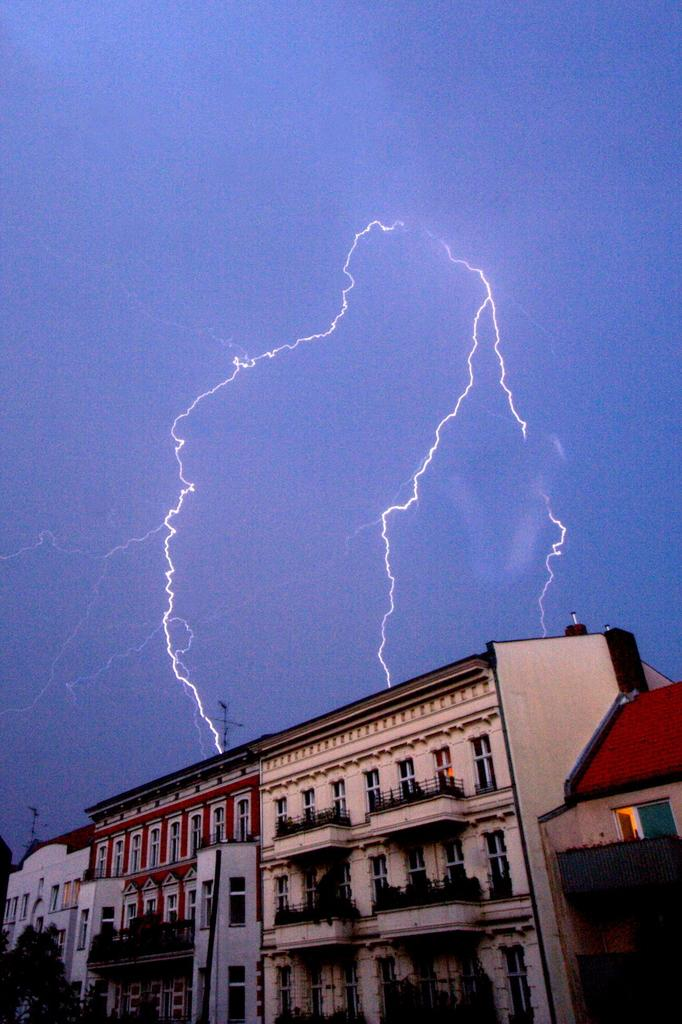What type of structure is located at the bottom of the image? There is a building at the bottom of the image. What are the vertical supports in the image? There are poles in the image. What are the barriers made of in the image? There are fences in the image. What type of vegetation can be seen in the image? There are trees and plants in the image. What can be used for entering or exiting the building in the image? There are doors in the image. What is visible in the sky in the background of the image? There is thunder visible in the sky in the background of the image. How many accounts are visible in the image? There are no accounts present in the image. What direction is the wind blowing in the image? There is no wind visible in the image. How many clocks can be seen in the image? There are no clocks present in the image. 